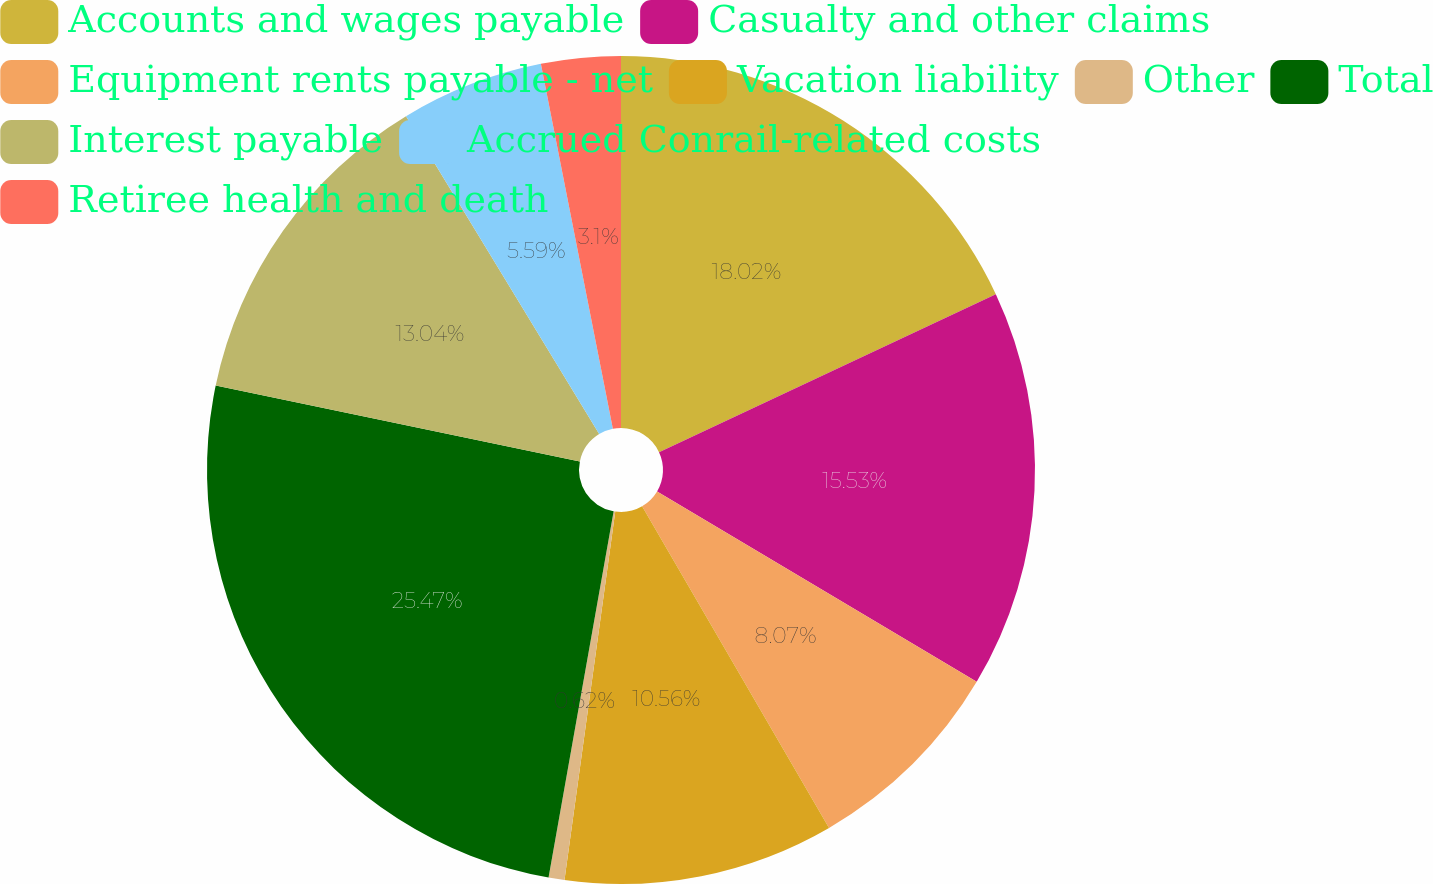Convert chart to OTSL. <chart><loc_0><loc_0><loc_500><loc_500><pie_chart><fcel>Accounts and wages payable<fcel>Casualty and other claims<fcel>Equipment rents payable - net<fcel>Vacation liability<fcel>Other<fcel>Total<fcel>Interest payable<fcel>Accrued Conrail-related costs<fcel>Retiree health and death<nl><fcel>18.02%<fcel>15.53%<fcel>8.07%<fcel>10.56%<fcel>0.62%<fcel>25.47%<fcel>13.04%<fcel>5.59%<fcel>3.1%<nl></chart> 